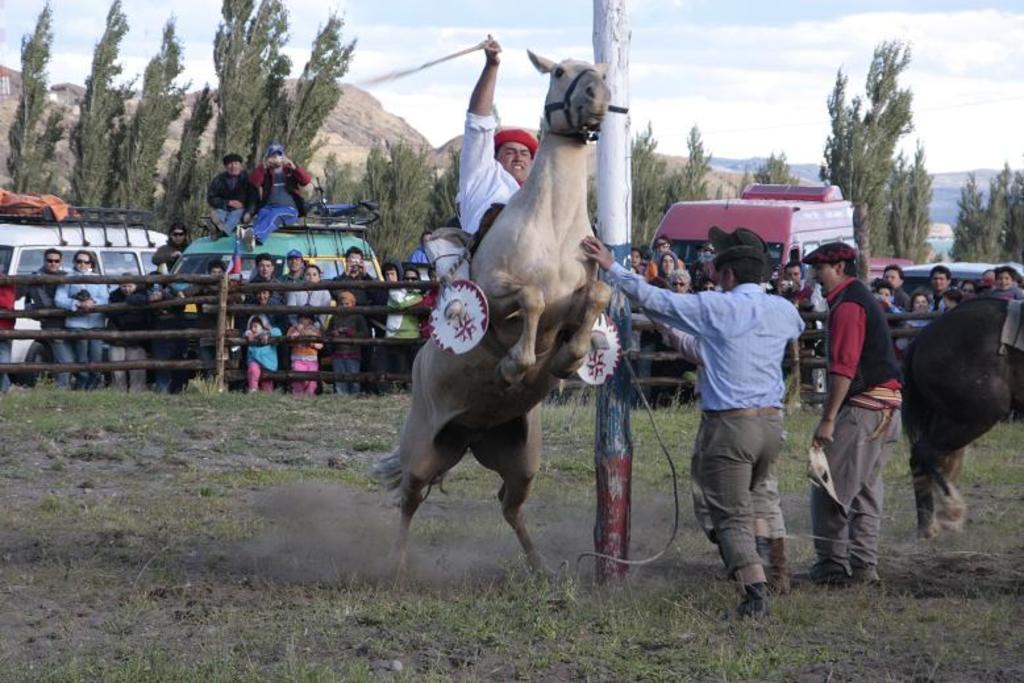Could you give a brief overview of what you see in this image? In this picture I can see a man riding the horse in the middle, beside him few men are standing and there is a pole, in the background there is a wooden fence. A group of people are standing and looking at this person and also I can see few vehicles, trees. At the top I can see the sky. 